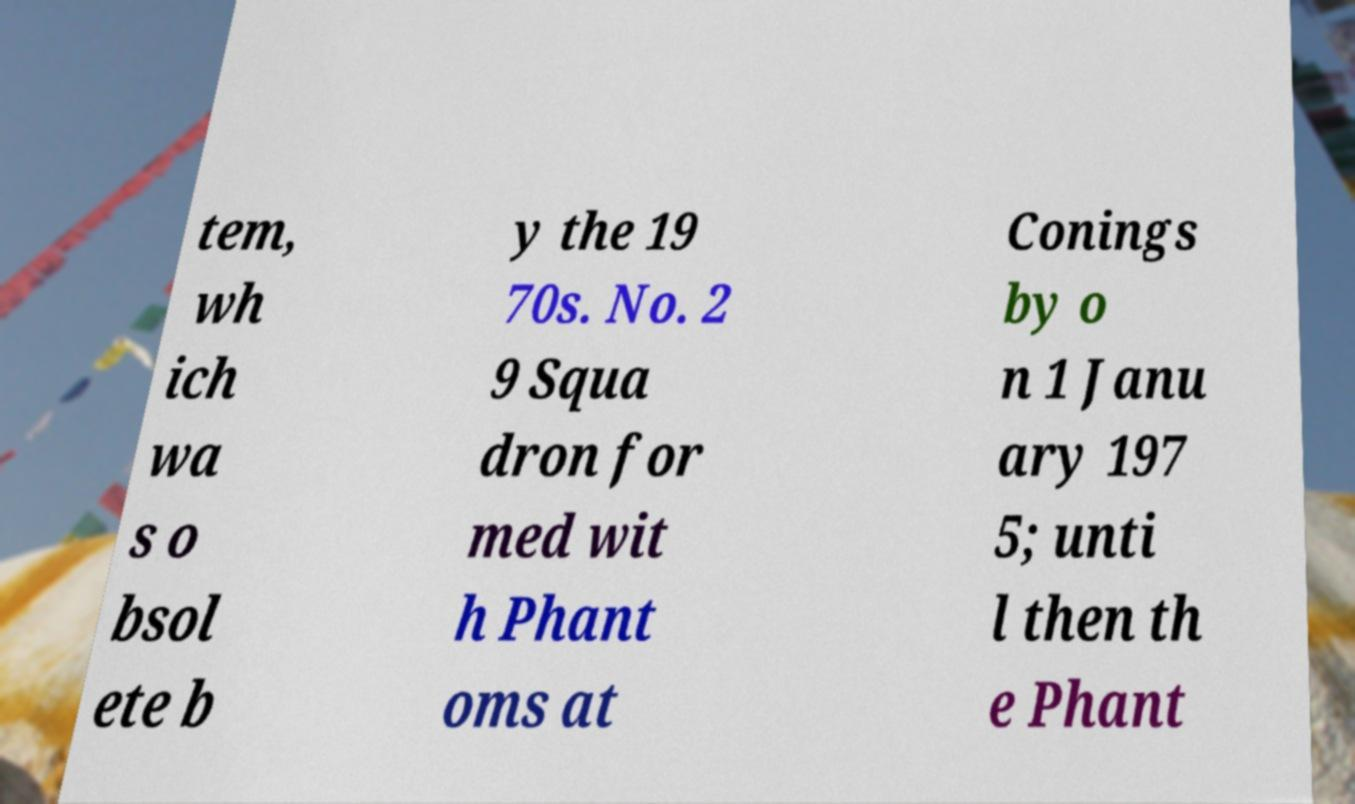What messages or text are displayed in this image? I need them in a readable, typed format. tem, wh ich wa s o bsol ete b y the 19 70s. No. 2 9 Squa dron for med wit h Phant oms at Conings by o n 1 Janu ary 197 5; unti l then th e Phant 